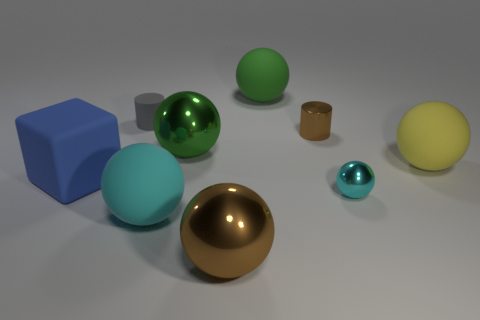What material is the small brown cylinder?
Offer a very short reply. Metal. What color is the matte object that is both to the right of the tiny gray object and left of the large brown shiny sphere?
Offer a very short reply. Cyan. Are there the same number of cylinders in front of the big blue thing and cyan matte spheres that are behind the big cyan object?
Make the answer very short. Yes. The big block that is made of the same material as the tiny gray cylinder is what color?
Provide a short and direct response. Blue. There is a tiny matte object; is it the same color as the big metallic sphere in front of the blue matte block?
Your response must be concise. No. Are there any tiny rubber cylinders that are in front of the cylinder to the right of the rubber ball in front of the small cyan metallic thing?
Make the answer very short. No. What shape is the big yellow thing that is the same material as the large block?
Provide a succinct answer. Sphere. Are there any other things that are the same shape as the yellow matte thing?
Offer a very short reply. Yes. The large cyan matte object is what shape?
Make the answer very short. Sphere. Do the rubber object that is left of the small matte cylinder and the yellow thing have the same shape?
Give a very brief answer. No. 